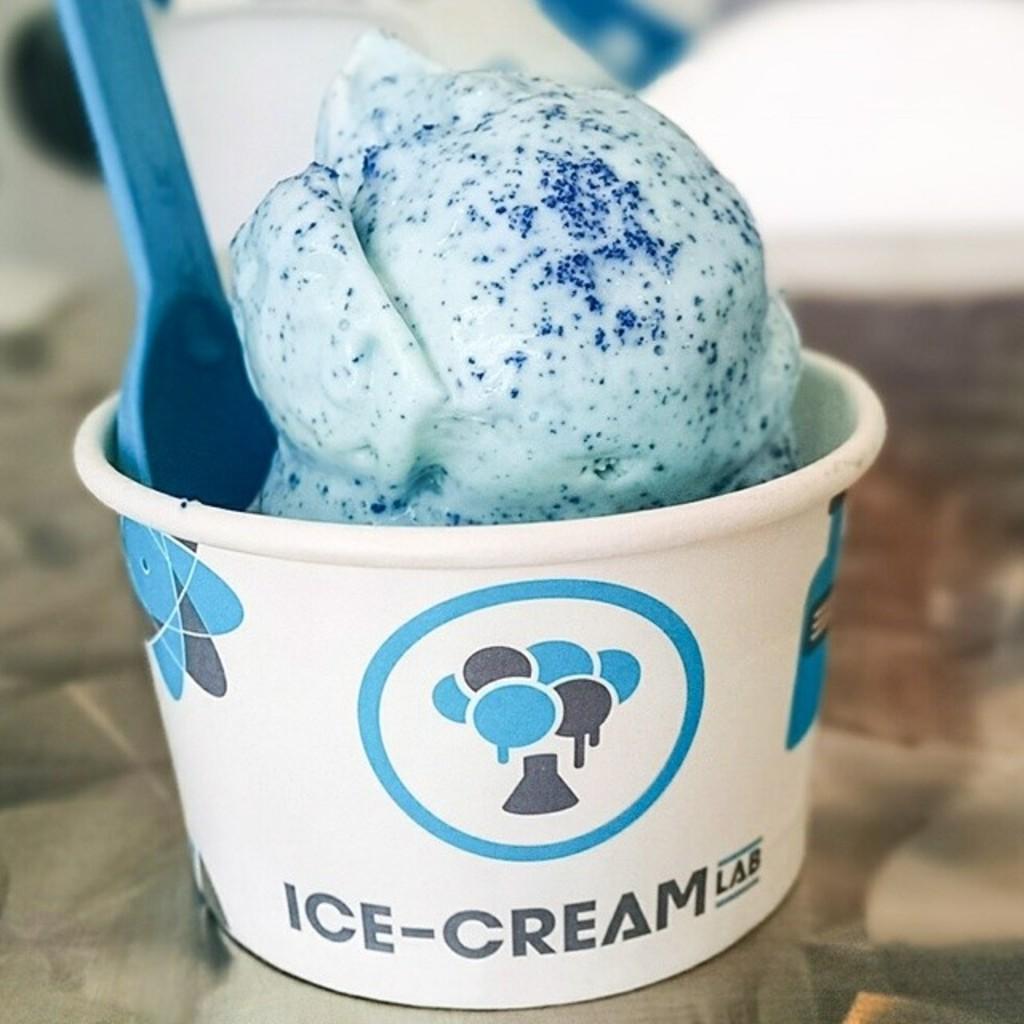In one or two sentences, can you explain what this image depicts? In the picture we can see a ice cream on the table and we can see the cup, the cream ball, and a spoon in it. On the cup it is written as ice-cream lab. 